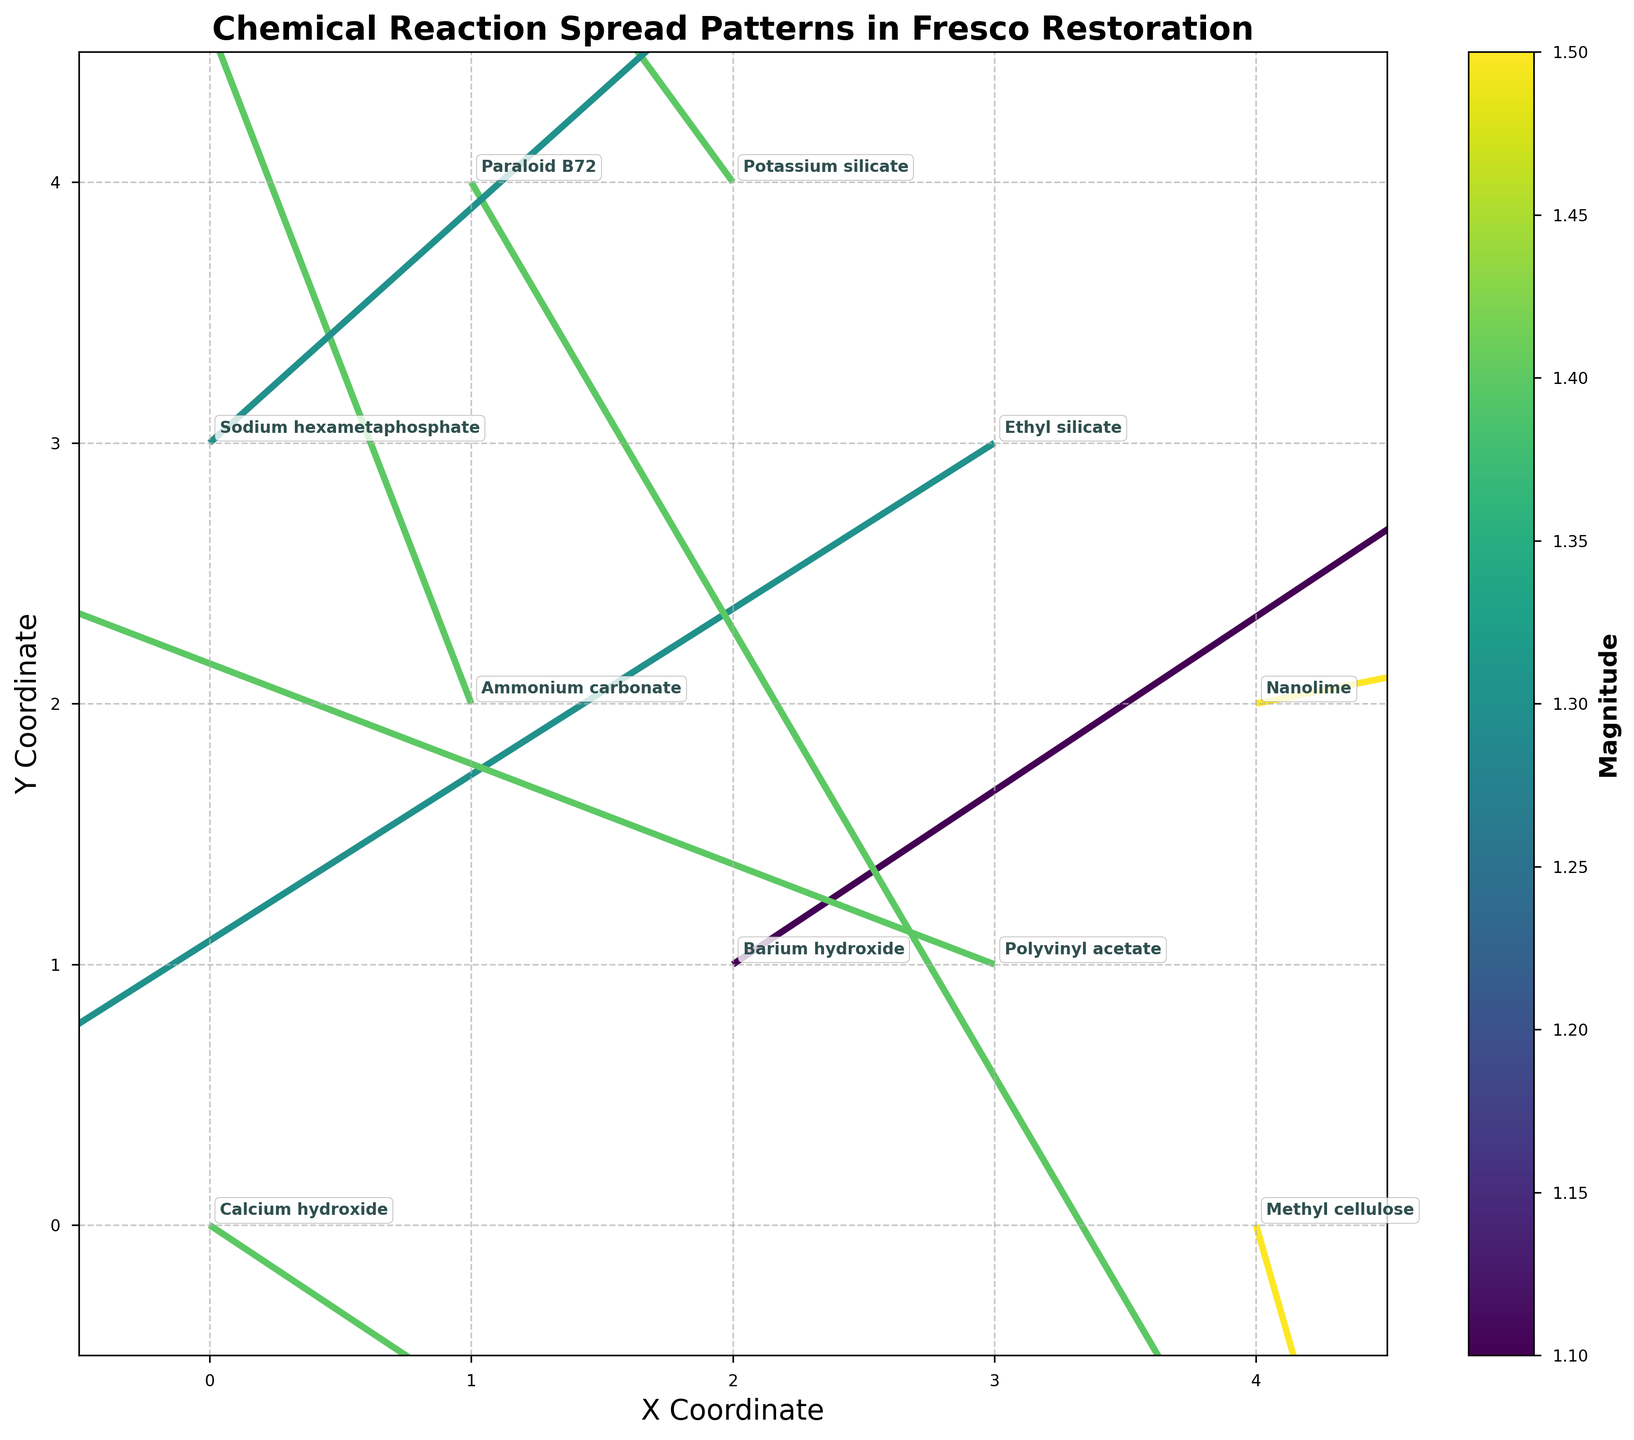How many chemicals are there in the figure? Count the number of different annotations in the plot, which represent different chemicals.
Answer: 10 What is the title of the figure? Look at the title text displayed at the top of the plot.
Answer: Chemical Reaction Spread Patterns in Fresco Restoration Which chemical is located at coordinates (4,2)? Find the annotation text located at (4,2) on the plot.
Answer: Nanolime Which vector has the highest magnitude and what is its chemical? Identify the vector with the most intense color or the highest magnitude value on the color scale, then read the corresponding annotation.
Answer: Methyl cellulose What is the direction of the vector at coordinate (1,2)? Refer to the arrow at (1,2) to determine its direction (u: -0.5, v: 1.3).
Answer: Left and up What chemical exhibits the smallest u-component value and what is that value? Identify the vector with the smallest u-component by looking at each vector’s horizontal component.
Answer: Polyvinyl acetate, -1.3 Which chemical has vectors indicating movement predominantly upward? Look for vectors with positive v-components and match them with their corresponding annotations.
Answer: Ammonium carbonate Which chemical's vector points mainly downward and to the left and where is it located? Look for vectors with negative u and v-components, and then find the location and corresponding annotation.
Answer: Ethyl silicate, (3,3) What are the coordinates that have chemical vectors with magnitudes of 1.4? Identify the vectors that match the magnitude of 1.4 by their color on the color scale, then find their coordinates.
Answer: (0,0), (1,2), (1,4), (2,4), (3,1) What is the average magnitude of the vectors at the x-coordinate of 2? Sum the magnitudes of the vectors at x=2 and divide by the number of those vectors.
Answer: (1.1 + 1.4) / 2 = 1.25 